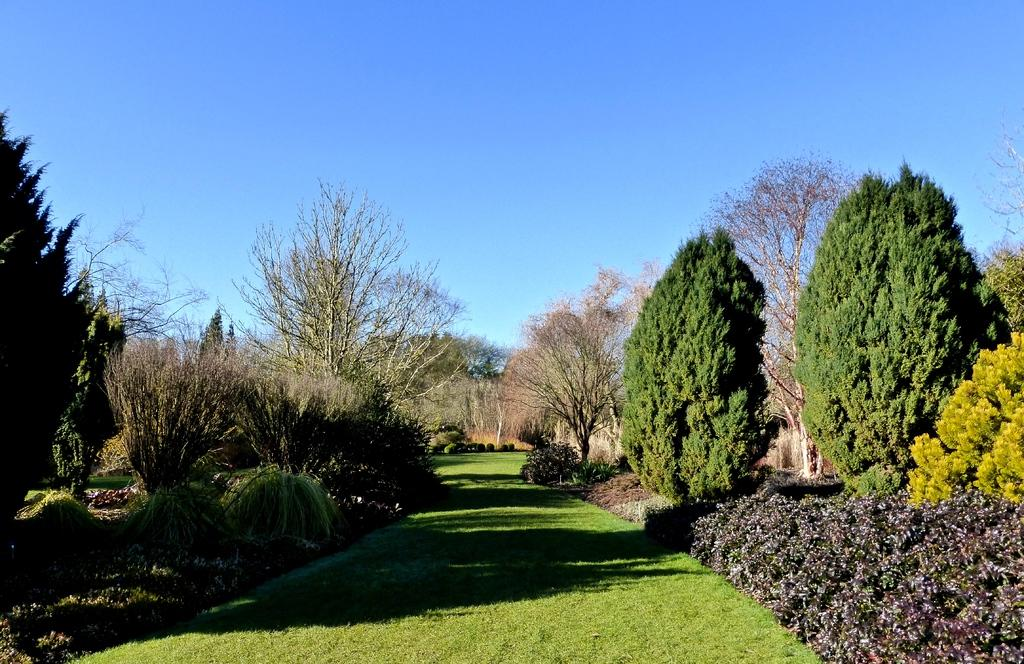What type of ground covering is visible in the image? The ground in the image is covered with grass. What other vegetation can be seen on both sides of the ground? There are plants and bushes on both sides of the ground. How many trees are present in the image? There are many trees in the image. What is the condition of the sky in the image? The sky is clear in the image. What type of liquid is being poured from the bottle in the image? There is no bottle or liquid present in the image. 